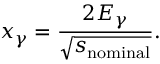Convert formula to latex. <formula><loc_0><loc_0><loc_500><loc_500>x _ { \gamma } = \frac { 2 E _ { \gamma } } { \sqrt { s _ { n o \min a l } } } .</formula> 